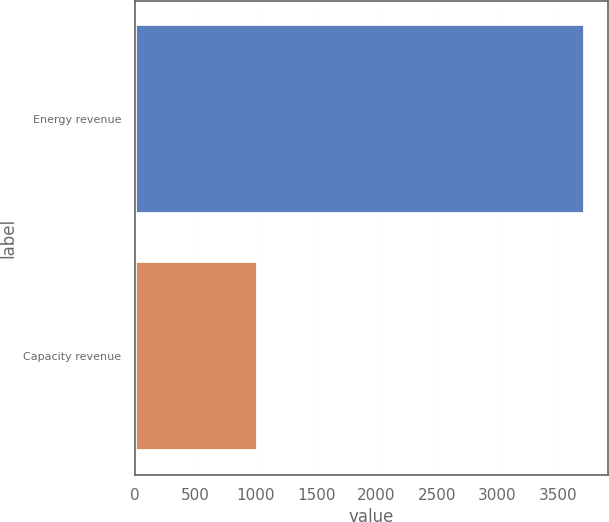<chart> <loc_0><loc_0><loc_500><loc_500><bar_chart><fcel>Energy revenue<fcel>Capacity revenue<nl><fcel>3726<fcel>1023<nl></chart> 